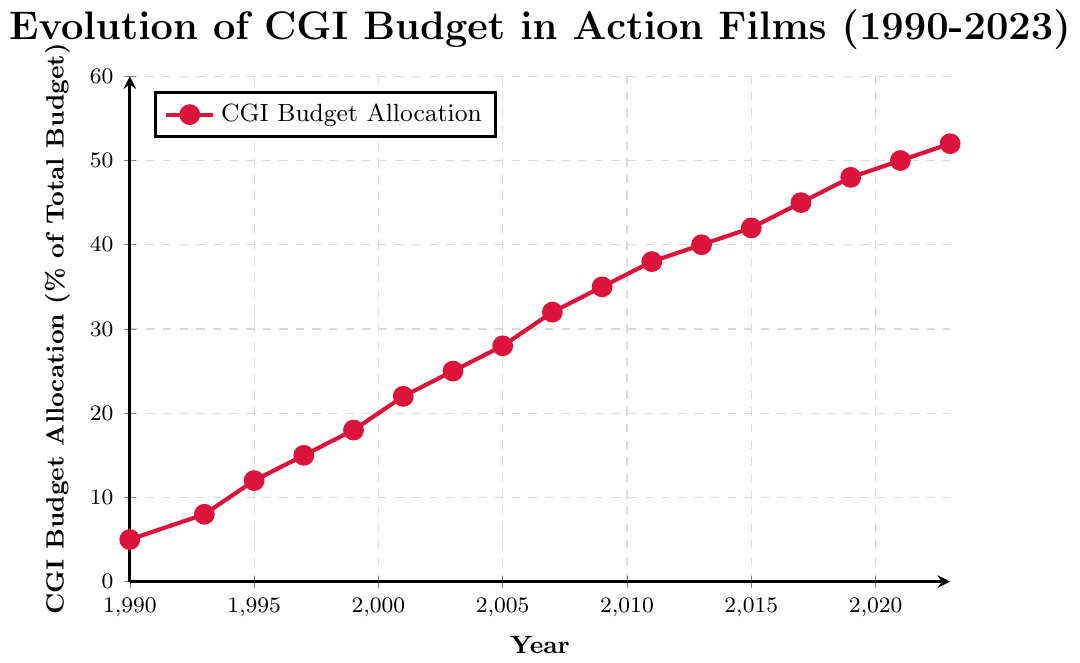What was the CGI budget allocation percentage in 2013? Locate the data point on the figure corresponding to the year 2013. The point aligns with the y-axis value of 40%.
Answer: 40% How has the CGI budget allocation changed from 1990 to 2023? Observe the CGI budget allocation in 1990 which is 5%, and then in 2023 which is 52%. Calculate the difference: 52% - 5% = 47%.
Answer: Increased by 47% Which year had the highest CGI budget allocation? Look at the highest point on the plot. The year corresponding to this maximum value is 2023
Answer: 2023 By how much did the CGI budget allocation increase between 2001 and 2009? In 2001, the allocation was 22% and in 2009, it was 35%. Calculate the difference: 35% - 22% = 13%.
Answer: 13% How does the CGI budget allocation in 1999 compare to that in 2017? In 1999, the allocation is 18%, and in 2017, it is 45%. The 2017 value is higher.
Answer: 2017 is higher What trend do you observe in CGI budget allocation from 1995 to 2011? From 1995 (12%) to 2011 (38%), the allocation consistently increases from 12% to 38%.
Answer: Consistent increase What is the average CGI budget allocation percentage from 1990 to 1999? Add the percentages: 5 + 8 + 12 + 15 + 18 = 58. Divide by the number of years (5): 58/5 = 11.6%.
Answer: 11.6% Which years have an equal or greater CGI budget allocation than 30%? Locate points where the y-axis value is 30% or more: 2007 (32%), 2009 (35%), 2011 (38%), 2013 (40%), 2015 (42%), 2017 (45%), 2019 (48%), 2021 (50%), and 2023 (52%).
Answer: 2007, 2009, 2011, 2013, 2015, 2017, 2019, 2021, 2023 What was the difference in CGI budget allocation between 1995 and 1997? In 1995, it was 12% and in 1997, it was 15%. Calculate the difference: 15% - 12% = 3%.
Answer: 3% What can be inferred regarding the CGI budget trend in action films from 1990 to 2023? The allocation shows a consistent upward trend from 5% in 1990 to 52% in 2023.
Answer: Increasing trend 